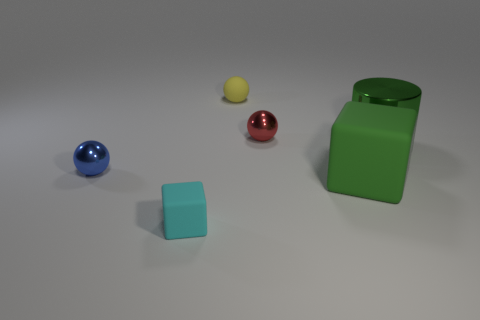Subtract all shiny spheres. How many spheres are left? 1 Add 2 green objects. How many objects exist? 8 Subtract all cyan cubes. How many cubes are left? 1 Subtract 1 green cylinders. How many objects are left? 5 Subtract all cubes. How many objects are left? 4 Subtract 3 balls. How many balls are left? 0 Subtract all blue blocks. Subtract all brown cylinders. How many blocks are left? 2 Subtract all yellow blocks. How many gray cylinders are left? 0 Subtract all large gray matte spheres. Subtract all small yellow balls. How many objects are left? 5 Add 6 small cyan rubber things. How many small cyan rubber things are left? 7 